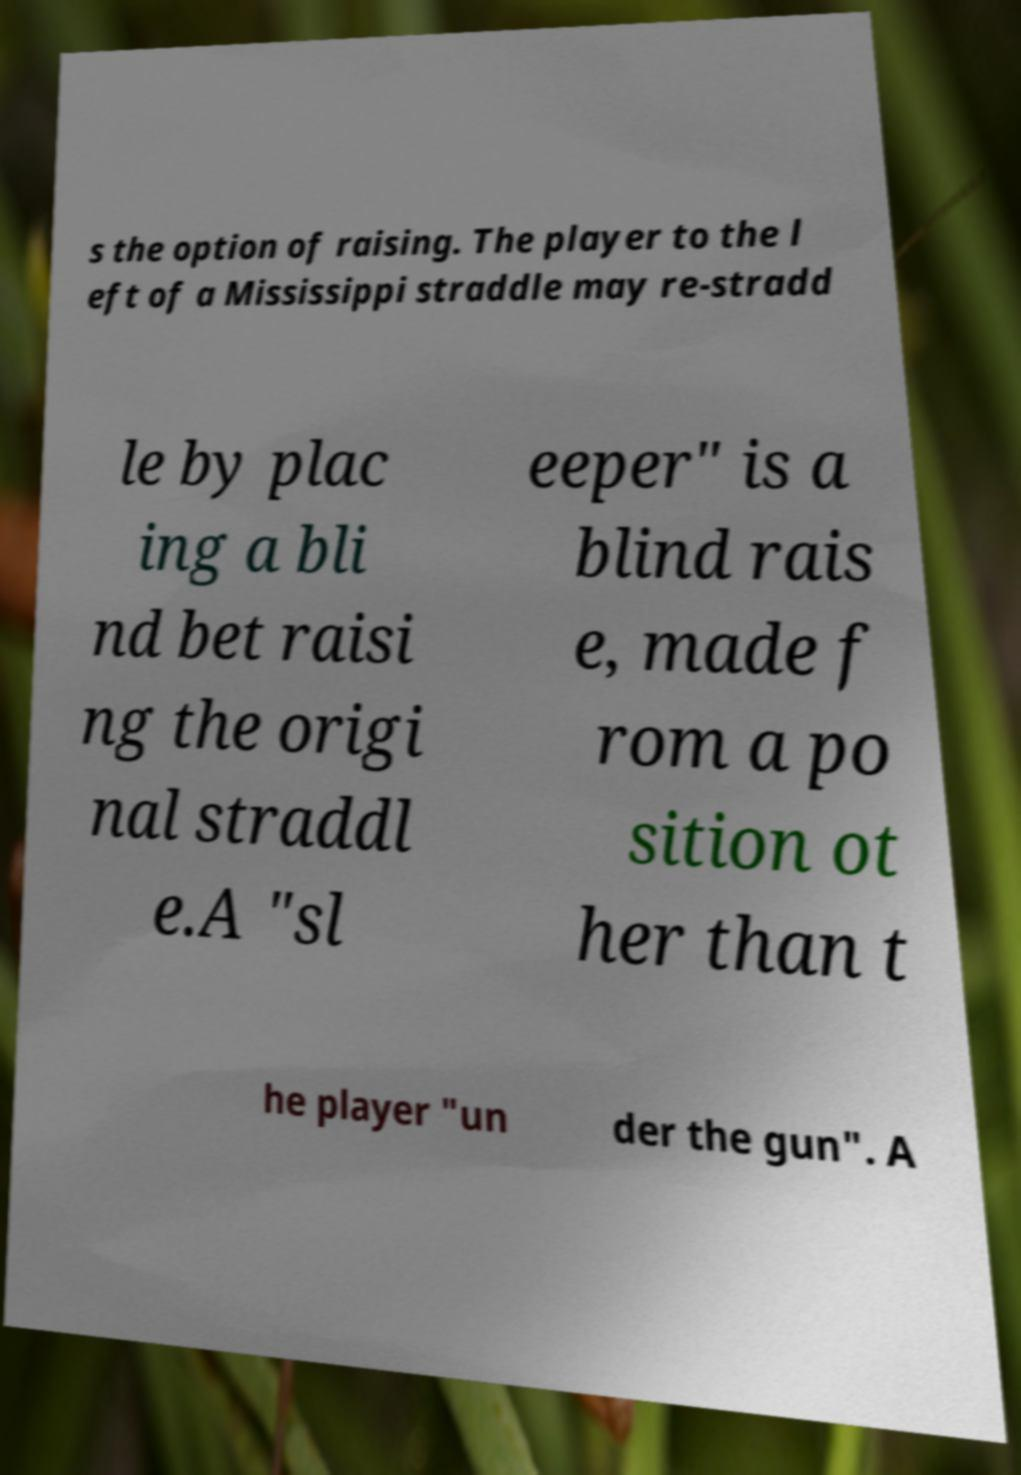Could you extract and type out the text from this image? s the option of raising. The player to the l eft of a Mississippi straddle may re-stradd le by plac ing a bli nd bet raisi ng the origi nal straddl e.A "sl eeper" is a blind rais e, made f rom a po sition ot her than t he player "un der the gun". A 